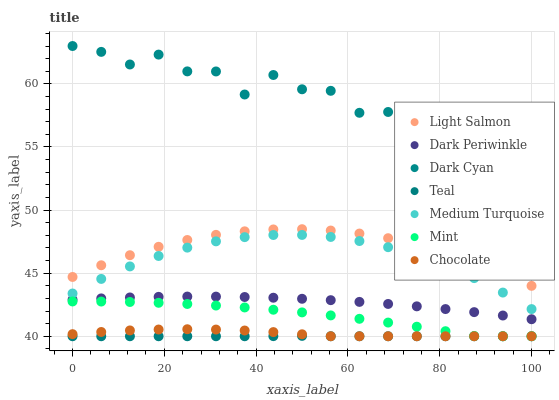Does Teal have the minimum area under the curve?
Answer yes or no. Yes. Does Dark Cyan have the maximum area under the curve?
Answer yes or no. Yes. Does Medium Turquoise have the minimum area under the curve?
Answer yes or no. No. Does Medium Turquoise have the maximum area under the curve?
Answer yes or no. No. Is Teal the smoothest?
Answer yes or no. Yes. Is Dark Cyan the roughest?
Answer yes or no. Yes. Is Medium Turquoise the smoothest?
Answer yes or no. No. Is Medium Turquoise the roughest?
Answer yes or no. No. Does Chocolate have the lowest value?
Answer yes or no. Yes. Does Medium Turquoise have the lowest value?
Answer yes or no. No. Does Dark Cyan have the highest value?
Answer yes or no. Yes. Does Medium Turquoise have the highest value?
Answer yes or no. No. Is Chocolate less than Dark Periwinkle?
Answer yes or no. Yes. Is Medium Turquoise greater than Mint?
Answer yes or no. Yes. Does Teal intersect Chocolate?
Answer yes or no. Yes. Is Teal less than Chocolate?
Answer yes or no. No. Is Teal greater than Chocolate?
Answer yes or no. No. Does Chocolate intersect Dark Periwinkle?
Answer yes or no. No. 